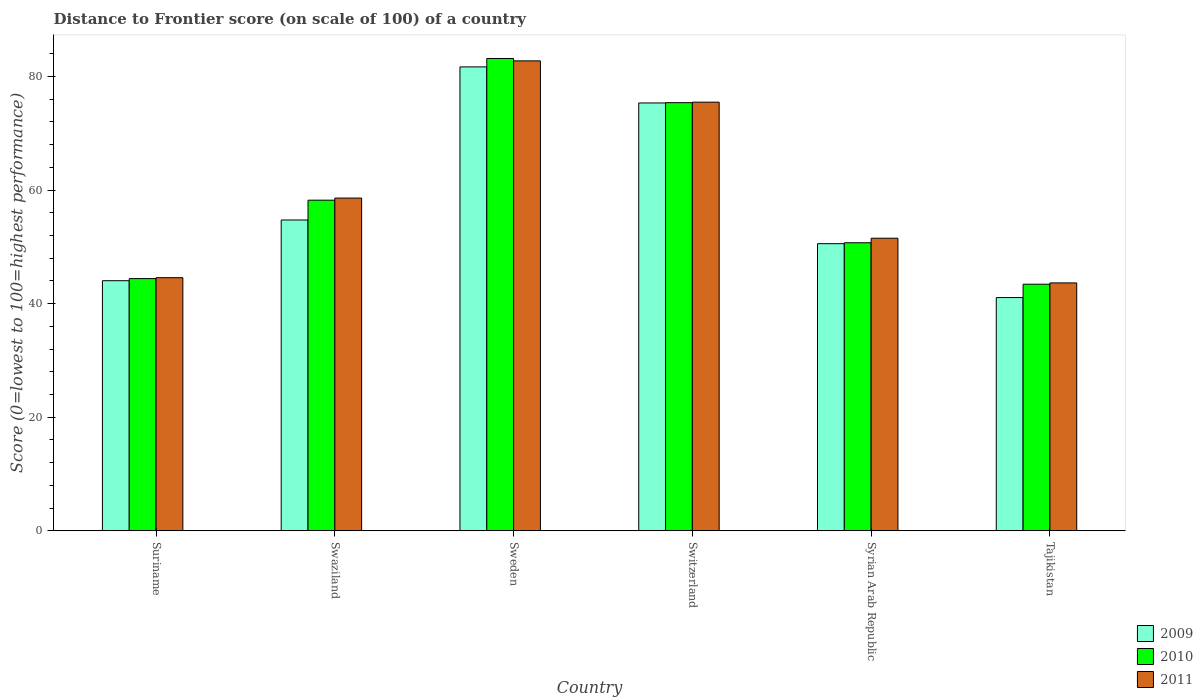How many bars are there on the 5th tick from the left?
Your answer should be compact. 3. What is the label of the 1st group of bars from the left?
Offer a terse response. Suriname. What is the distance to frontier score of in 2011 in Suriname?
Make the answer very short. 44.57. Across all countries, what is the maximum distance to frontier score of in 2010?
Your answer should be compact. 83.17. Across all countries, what is the minimum distance to frontier score of in 2009?
Provide a short and direct response. 41.07. In which country was the distance to frontier score of in 2011 minimum?
Provide a succinct answer. Tajikistan. What is the total distance to frontier score of in 2009 in the graph?
Make the answer very short. 347.43. What is the difference between the distance to frontier score of in 2009 in Switzerland and that in Syrian Arab Republic?
Keep it short and to the point. 24.78. What is the difference between the distance to frontier score of in 2010 in Swaziland and the distance to frontier score of in 2011 in Suriname?
Make the answer very short. 13.65. What is the average distance to frontier score of in 2010 per country?
Make the answer very short. 59.22. What is the difference between the distance to frontier score of of/in 2009 and distance to frontier score of of/in 2010 in Syrian Arab Republic?
Ensure brevity in your answer.  -0.16. In how many countries, is the distance to frontier score of in 2009 greater than 4?
Your response must be concise. 6. What is the ratio of the distance to frontier score of in 2011 in Syrian Arab Republic to that in Tajikistan?
Your answer should be compact. 1.18. Is the difference between the distance to frontier score of in 2009 in Syrian Arab Republic and Tajikistan greater than the difference between the distance to frontier score of in 2010 in Syrian Arab Republic and Tajikistan?
Ensure brevity in your answer.  Yes. What is the difference between the highest and the second highest distance to frontier score of in 2010?
Give a very brief answer. -7.78. What is the difference between the highest and the lowest distance to frontier score of in 2011?
Give a very brief answer. 39.1. Is it the case that in every country, the sum of the distance to frontier score of in 2010 and distance to frontier score of in 2009 is greater than the distance to frontier score of in 2011?
Make the answer very short. Yes. Are all the bars in the graph horizontal?
Your response must be concise. No. What is the difference between two consecutive major ticks on the Y-axis?
Your answer should be compact. 20. Are the values on the major ticks of Y-axis written in scientific E-notation?
Your answer should be compact. No. How many legend labels are there?
Your response must be concise. 3. How are the legend labels stacked?
Offer a terse response. Vertical. What is the title of the graph?
Ensure brevity in your answer.  Distance to Frontier score (on scale of 100) of a country. Does "2001" appear as one of the legend labels in the graph?
Provide a short and direct response. No. What is the label or title of the Y-axis?
Provide a short and direct response. Score (0=lowest to 100=highest performance). What is the Score (0=lowest to 100=highest performance) in 2009 in Suriname?
Offer a very short reply. 44.04. What is the Score (0=lowest to 100=highest performance) in 2010 in Suriname?
Provide a succinct answer. 44.41. What is the Score (0=lowest to 100=highest performance) in 2011 in Suriname?
Make the answer very short. 44.57. What is the Score (0=lowest to 100=highest performance) of 2009 in Swaziland?
Offer a very short reply. 54.73. What is the Score (0=lowest to 100=highest performance) in 2010 in Swaziland?
Give a very brief answer. 58.22. What is the Score (0=lowest to 100=highest performance) in 2011 in Swaziland?
Keep it short and to the point. 58.59. What is the Score (0=lowest to 100=highest performance) of 2009 in Sweden?
Provide a short and direct response. 81.69. What is the Score (0=lowest to 100=highest performance) of 2010 in Sweden?
Give a very brief answer. 83.17. What is the Score (0=lowest to 100=highest performance) in 2011 in Sweden?
Ensure brevity in your answer.  82.75. What is the Score (0=lowest to 100=highest performance) in 2009 in Switzerland?
Make the answer very short. 75.34. What is the Score (0=lowest to 100=highest performance) of 2010 in Switzerland?
Your answer should be very brief. 75.39. What is the Score (0=lowest to 100=highest performance) of 2011 in Switzerland?
Provide a succinct answer. 75.48. What is the Score (0=lowest to 100=highest performance) of 2009 in Syrian Arab Republic?
Provide a succinct answer. 50.56. What is the Score (0=lowest to 100=highest performance) of 2010 in Syrian Arab Republic?
Your answer should be very brief. 50.72. What is the Score (0=lowest to 100=highest performance) in 2011 in Syrian Arab Republic?
Provide a succinct answer. 51.52. What is the Score (0=lowest to 100=highest performance) of 2009 in Tajikistan?
Your answer should be very brief. 41.07. What is the Score (0=lowest to 100=highest performance) of 2010 in Tajikistan?
Ensure brevity in your answer.  43.42. What is the Score (0=lowest to 100=highest performance) in 2011 in Tajikistan?
Provide a short and direct response. 43.65. Across all countries, what is the maximum Score (0=lowest to 100=highest performance) of 2009?
Keep it short and to the point. 81.69. Across all countries, what is the maximum Score (0=lowest to 100=highest performance) in 2010?
Offer a very short reply. 83.17. Across all countries, what is the maximum Score (0=lowest to 100=highest performance) in 2011?
Give a very brief answer. 82.75. Across all countries, what is the minimum Score (0=lowest to 100=highest performance) of 2009?
Your answer should be compact. 41.07. Across all countries, what is the minimum Score (0=lowest to 100=highest performance) in 2010?
Offer a terse response. 43.42. Across all countries, what is the minimum Score (0=lowest to 100=highest performance) of 2011?
Your answer should be compact. 43.65. What is the total Score (0=lowest to 100=highest performance) of 2009 in the graph?
Your answer should be very brief. 347.43. What is the total Score (0=lowest to 100=highest performance) in 2010 in the graph?
Your answer should be very brief. 355.33. What is the total Score (0=lowest to 100=highest performance) in 2011 in the graph?
Give a very brief answer. 356.56. What is the difference between the Score (0=lowest to 100=highest performance) of 2009 in Suriname and that in Swaziland?
Provide a short and direct response. -10.69. What is the difference between the Score (0=lowest to 100=highest performance) in 2010 in Suriname and that in Swaziland?
Offer a terse response. -13.81. What is the difference between the Score (0=lowest to 100=highest performance) of 2011 in Suriname and that in Swaziland?
Your response must be concise. -14.02. What is the difference between the Score (0=lowest to 100=highest performance) of 2009 in Suriname and that in Sweden?
Your answer should be very brief. -37.65. What is the difference between the Score (0=lowest to 100=highest performance) in 2010 in Suriname and that in Sweden?
Make the answer very short. -38.76. What is the difference between the Score (0=lowest to 100=highest performance) in 2011 in Suriname and that in Sweden?
Your answer should be very brief. -38.18. What is the difference between the Score (0=lowest to 100=highest performance) of 2009 in Suriname and that in Switzerland?
Offer a very short reply. -31.3. What is the difference between the Score (0=lowest to 100=highest performance) of 2010 in Suriname and that in Switzerland?
Your answer should be very brief. -30.98. What is the difference between the Score (0=lowest to 100=highest performance) in 2011 in Suriname and that in Switzerland?
Your answer should be compact. -30.91. What is the difference between the Score (0=lowest to 100=highest performance) of 2009 in Suriname and that in Syrian Arab Republic?
Your answer should be compact. -6.52. What is the difference between the Score (0=lowest to 100=highest performance) of 2010 in Suriname and that in Syrian Arab Republic?
Ensure brevity in your answer.  -6.31. What is the difference between the Score (0=lowest to 100=highest performance) of 2011 in Suriname and that in Syrian Arab Republic?
Make the answer very short. -6.95. What is the difference between the Score (0=lowest to 100=highest performance) of 2009 in Suriname and that in Tajikistan?
Provide a succinct answer. 2.97. What is the difference between the Score (0=lowest to 100=highest performance) of 2010 in Suriname and that in Tajikistan?
Keep it short and to the point. 0.99. What is the difference between the Score (0=lowest to 100=highest performance) of 2009 in Swaziland and that in Sweden?
Your answer should be very brief. -26.96. What is the difference between the Score (0=lowest to 100=highest performance) in 2010 in Swaziland and that in Sweden?
Offer a very short reply. -24.95. What is the difference between the Score (0=lowest to 100=highest performance) in 2011 in Swaziland and that in Sweden?
Ensure brevity in your answer.  -24.16. What is the difference between the Score (0=lowest to 100=highest performance) in 2009 in Swaziland and that in Switzerland?
Your answer should be compact. -20.61. What is the difference between the Score (0=lowest to 100=highest performance) in 2010 in Swaziland and that in Switzerland?
Your response must be concise. -17.17. What is the difference between the Score (0=lowest to 100=highest performance) of 2011 in Swaziland and that in Switzerland?
Offer a terse response. -16.89. What is the difference between the Score (0=lowest to 100=highest performance) of 2009 in Swaziland and that in Syrian Arab Republic?
Offer a terse response. 4.17. What is the difference between the Score (0=lowest to 100=highest performance) in 2010 in Swaziland and that in Syrian Arab Republic?
Provide a short and direct response. 7.5. What is the difference between the Score (0=lowest to 100=highest performance) in 2011 in Swaziland and that in Syrian Arab Republic?
Provide a succinct answer. 7.07. What is the difference between the Score (0=lowest to 100=highest performance) in 2009 in Swaziland and that in Tajikistan?
Make the answer very short. 13.66. What is the difference between the Score (0=lowest to 100=highest performance) in 2010 in Swaziland and that in Tajikistan?
Keep it short and to the point. 14.8. What is the difference between the Score (0=lowest to 100=highest performance) in 2011 in Swaziland and that in Tajikistan?
Your answer should be compact. 14.94. What is the difference between the Score (0=lowest to 100=highest performance) of 2009 in Sweden and that in Switzerland?
Offer a very short reply. 6.35. What is the difference between the Score (0=lowest to 100=highest performance) of 2010 in Sweden and that in Switzerland?
Provide a succinct answer. 7.78. What is the difference between the Score (0=lowest to 100=highest performance) of 2011 in Sweden and that in Switzerland?
Provide a short and direct response. 7.27. What is the difference between the Score (0=lowest to 100=highest performance) in 2009 in Sweden and that in Syrian Arab Republic?
Your answer should be compact. 31.13. What is the difference between the Score (0=lowest to 100=highest performance) of 2010 in Sweden and that in Syrian Arab Republic?
Provide a short and direct response. 32.45. What is the difference between the Score (0=lowest to 100=highest performance) in 2011 in Sweden and that in Syrian Arab Republic?
Keep it short and to the point. 31.23. What is the difference between the Score (0=lowest to 100=highest performance) in 2009 in Sweden and that in Tajikistan?
Ensure brevity in your answer.  40.62. What is the difference between the Score (0=lowest to 100=highest performance) in 2010 in Sweden and that in Tajikistan?
Ensure brevity in your answer.  39.75. What is the difference between the Score (0=lowest to 100=highest performance) in 2011 in Sweden and that in Tajikistan?
Provide a succinct answer. 39.1. What is the difference between the Score (0=lowest to 100=highest performance) in 2009 in Switzerland and that in Syrian Arab Republic?
Your answer should be compact. 24.78. What is the difference between the Score (0=lowest to 100=highest performance) in 2010 in Switzerland and that in Syrian Arab Republic?
Give a very brief answer. 24.67. What is the difference between the Score (0=lowest to 100=highest performance) of 2011 in Switzerland and that in Syrian Arab Republic?
Provide a succinct answer. 23.96. What is the difference between the Score (0=lowest to 100=highest performance) in 2009 in Switzerland and that in Tajikistan?
Make the answer very short. 34.27. What is the difference between the Score (0=lowest to 100=highest performance) in 2010 in Switzerland and that in Tajikistan?
Offer a very short reply. 31.97. What is the difference between the Score (0=lowest to 100=highest performance) of 2011 in Switzerland and that in Tajikistan?
Offer a very short reply. 31.83. What is the difference between the Score (0=lowest to 100=highest performance) in 2009 in Syrian Arab Republic and that in Tajikistan?
Provide a short and direct response. 9.49. What is the difference between the Score (0=lowest to 100=highest performance) in 2011 in Syrian Arab Republic and that in Tajikistan?
Ensure brevity in your answer.  7.87. What is the difference between the Score (0=lowest to 100=highest performance) in 2009 in Suriname and the Score (0=lowest to 100=highest performance) in 2010 in Swaziland?
Your answer should be very brief. -14.18. What is the difference between the Score (0=lowest to 100=highest performance) of 2009 in Suriname and the Score (0=lowest to 100=highest performance) of 2011 in Swaziland?
Keep it short and to the point. -14.55. What is the difference between the Score (0=lowest to 100=highest performance) in 2010 in Suriname and the Score (0=lowest to 100=highest performance) in 2011 in Swaziland?
Your answer should be very brief. -14.18. What is the difference between the Score (0=lowest to 100=highest performance) in 2009 in Suriname and the Score (0=lowest to 100=highest performance) in 2010 in Sweden?
Keep it short and to the point. -39.13. What is the difference between the Score (0=lowest to 100=highest performance) of 2009 in Suriname and the Score (0=lowest to 100=highest performance) of 2011 in Sweden?
Provide a succinct answer. -38.71. What is the difference between the Score (0=lowest to 100=highest performance) in 2010 in Suriname and the Score (0=lowest to 100=highest performance) in 2011 in Sweden?
Ensure brevity in your answer.  -38.34. What is the difference between the Score (0=lowest to 100=highest performance) in 2009 in Suriname and the Score (0=lowest to 100=highest performance) in 2010 in Switzerland?
Your response must be concise. -31.35. What is the difference between the Score (0=lowest to 100=highest performance) of 2009 in Suriname and the Score (0=lowest to 100=highest performance) of 2011 in Switzerland?
Provide a short and direct response. -31.44. What is the difference between the Score (0=lowest to 100=highest performance) in 2010 in Suriname and the Score (0=lowest to 100=highest performance) in 2011 in Switzerland?
Offer a terse response. -31.07. What is the difference between the Score (0=lowest to 100=highest performance) of 2009 in Suriname and the Score (0=lowest to 100=highest performance) of 2010 in Syrian Arab Republic?
Give a very brief answer. -6.68. What is the difference between the Score (0=lowest to 100=highest performance) in 2009 in Suriname and the Score (0=lowest to 100=highest performance) in 2011 in Syrian Arab Republic?
Your response must be concise. -7.48. What is the difference between the Score (0=lowest to 100=highest performance) of 2010 in Suriname and the Score (0=lowest to 100=highest performance) of 2011 in Syrian Arab Republic?
Offer a terse response. -7.11. What is the difference between the Score (0=lowest to 100=highest performance) in 2009 in Suriname and the Score (0=lowest to 100=highest performance) in 2010 in Tajikistan?
Your response must be concise. 0.62. What is the difference between the Score (0=lowest to 100=highest performance) in 2009 in Suriname and the Score (0=lowest to 100=highest performance) in 2011 in Tajikistan?
Provide a succinct answer. 0.39. What is the difference between the Score (0=lowest to 100=highest performance) of 2010 in Suriname and the Score (0=lowest to 100=highest performance) of 2011 in Tajikistan?
Keep it short and to the point. 0.76. What is the difference between the Score (0=lowest to 100=highest performance) in 2009 in Swaziland and the Score (0=lowest to 100=highest performance) in 2010 in Sweden?
Your answer should be very brief. -28.44. What is the difference between the Score (0=lowest to 100=highest performance) in 2009 in Swaziland and the Score (0=lowest to 100=highest performance) in 2011 in Sweden?
Keep it short and to the point. -28.02. What is the difference between the Score (0=lowest to 100=highest performance) in 2010 in Swaziland and the Score (0=lowest to 100=highest performance) in 2011 in Sweden?
Make the answer very short. -24.53. What is the difference between the Score (0=lowest to 100=highest performance) of 2009 in Swaziland and the Score (0=lowest to 100=highest performance) of 2010 in Switzerland?
Make the answer very short. -20.66. What is the difference between the Score (0=lowest to 100=highest performance) in 2009 in Swaziland and the Score (0=lowest to 100=highest performance) in 2011 in Switzerland?
Provide a short and direct response. -20.75. What is the difference between the Score (0=lowest to 100=highest performance) in 2010 in Swaziland and the Score (0=lowest to 100=highest performance) in 2011 in Switzerland?
Your answer should be very brief. -17.26. What is the difference between the Score (0=lowest to 100=highest performance) in 2009 in Swaziland and the Score (0=lowest to 100=highest performance) in 2010 in Syrian Arab Republic?
Your answer should be very brief. 4.01. What is the difference between the Score (0=lowest to 100=highest performance) in 2009 in Swaziland and the Score (0=lowest to 100=highest performance) in 2011 in Syrian Arab Republic?
Keep it short and to the point. 3.21. What is the difference between the Score (0=lowest to 100=highest performance) of 2009 in Swaziland and the Score (0=lowest to 100=highest performance) of 2010 in Tajikistan?
Offer a terse response. 11.31. What is the difference between the Score (0=lowest to 100=highest performance) in 2009 in Swaziland and the Score (0=lowest to 100=highest performance) in 2011 in Tajikistan?
Provide a short and direct response. 11.08. What is the difference between the Score (0=lowest to 100=highest performance) of 2010 in Swaziland and the Score (0=lowest to 100=highest performance) of 2011 in Tajikistan?
Offer a very short reply. 14.57. What is the difference between the Score (0=lowest to 100=highest performance) of 2009 in Sweden and the Score (0=lowest to 100=highest performance) of 2010 in Switzerland?
Your response must be concise. 6.3. What is the difference between the Score (0=lowest to 100=highest performance) in 2009 in Sweden and the Score (0=lowest to 100=highest performance) in 2011 in Switzerland?
Give a very brief answer. 6.21. What is the difference between the Score (0=lowest to 100=highest performance) of 2010 in Sweden and the Score (0=lowest to 100=highest performance) of 2011 in Switzerland?
Offer a very short reply. 7.69. What is the difference between the Score (0=lowest to 100=highest performance) of 2009 in Sweden and the Score (0=lowest to 100=highest performance) of 2010 in Syrian Arab Republic?
Provide a succinct answer. 30.97. What is the difference between the Score (0=lowest to 100=highest performance) of 2009 in Sweden and the Score (0=lowest to 100=highest performance) of 2011 in Syrian Arab Republic?
Give a very brief answer. 30.17. What is the difference between the Score (0=lowest to 100=highest performance) in 2010 in Sweden and the Score (0=lowest to 100=highest performance) in 2011 in Syrian Arab Republic?
Your answer should be very brief. 31.65. What is the difference between the Score (0=lowest to 100=highest performance) in 2009 in Sweden and the Score (0=lowest to 100=highest performance) in 2010 in Tajikistan?
Keep it short and to the point. 38.27. What is the difference between the Score (0=lowest to 100=highest performance) in 2009 in Sweden and the Score (0=lowest to 100=highest performance) in 2011 in Tajikistan?
Provide a short and direct response. 38.04. What is the difference between the Score (0=lowest to 100=highest performance) of 2010 in Sweden and the Score (0=lowest to 100=highest performance) of 2011 in Tajikistan?
Your response must be concise. 39.52. What is the difference between the Score (0=lowest to 100=highest performance) in 2009 in Switzerland and the Score (0=lowest to 100=highest performance) in 2010 in Syrian Arab Republic?
Make the answer very short. 24.62. What is the difference between the Score (0=lowest to 100=highest performance) in 2009 in Switzerland and the Score (0=lowest to 100=highest performance) in 2011 in Syrian Arab Republic?
Ensure brevity in your answer.  23.82. What is the difference between the Score (0=lowest to 100=highest performance) of 2010 in Switzerland and the Score (0=lowest to 100=highest performance) of 2011 in Syrian Arab Republic?
Ensure brevity in your answer.  23.87. What is the difference between the Score (0=lowest to 100=highest performance) of 2009 in Switzerland and the Score (0=lowest to 100=highest performance) of 2010 in Tajikistan?
Make the answer very short. 31.92. What is the difference between the Score (0=lowest to 100=highest performance) in 2009 in Switzerland and the Score (0=lowest to 100=highest performance) in 2011 in Tajikistan?
Provide a succinct answer. 31.69. What is the difference between the Score (0=lowest to 100=highest performance) of 2010 in Switzerland and the Score (0=lowest to 100=highest performance) of 2011 in Tajikistan?
Ensure brevity in your answer.  31.74. What is the difference between the Score (0=lowest to 100=highest performance) in 2009 in Syrian Arab Republic and the Score (0=lowest to 100=highest performance) in 2010 in Tajikistan?
Offer a terse response. 7.14. What is the difference between the Score (0=lowest to 100=highest performance) in 2009 in Syrian Arab Republic and the Score (0=lowest to 100=highest performance) in 2011 in Tajikistan?
Offer a terse response. 6.91. What is the difference between the Score (0=lowest to 100=highest performance) of 2010 in Syrian Arab Republic and the Score (0=lowest to 100=highest performance) of 2011 in Tajikistan?
Offer a very short reply. 7.07. What is the average Score (0=lowest to 100=highest performance) in 2009 per country?
Your response must be concise. 57.91. What is the average Score (0=lowest to 100=highest performance) of 2010 per country?
Provide a succinct answer. 59.22. What is the average Score (0=lowest to 100=highest performance) of 2011 per country?
Provide a short and direct response. 59.43. What is the difference between the Score (0=lowest to 100=highest performance) in 2009 and Score (0=lowest to 100=highest performance) in 2010 in Suriname?
Offer a terse response. -0.37. What is the difference between the Score (0=lowest to 100=highest performance) of 2009 and Score (0=lowest to 100=highest performance) of 2011 in Suriname?
Your answer should be very brief. -0.53. What is the difference between the Score (0=lowest to 100=highest performance) of 2010 and Score (0=lowest to 100=highest performance) of 2011 in Suriname?
Make the answer very short. -0.16. What is the difference between the Score (0=lowest to 100=highest performance) in 2009 and Score (0=lowest to 100=highest performance) in 2010 in Swaziland?
Give a very brief answer. -3.49. What is the difference between the Score (0=lowest to 100=highest performance) in 2009 and Score (0=lowest to 100=highest performance) in 2011 in Swaziland?
Provide a succinct answer. -3.86. What is the difference between the Score (0=lowest to 100=highest performance) of 2010 and Score (0=lowest to 100=highest performance) of 2011 in Swaziland?
Your answer should be very brief. -0.37. What is the difference between the Score (0=lowest to 100=highest performance) of 2009 and Score (0=lowest to 100=highest performance) of 2010 in Sweden?
Your response must be concise. -1.48. What is the difference between the Score (0=lowest to 100=highest performance) in 2009 and Score (0=lowest to 100=highest performance) in 2011 in Sweden?
Your answer should be compact. -1.06. What is the difference between the Score (0=lowest to 100=highest performance) of 2010 and Score (0=lowest to 100=highest performance) of 2011 in Sweden?
Your response must be concise. 0.42. What is the difference between the Score (0=lowest to 100=highest performance) of 2009 and Score (0=lowest to 100=highest performance) of 2010 in Switzerland?
Make the answer very short. -0.05. What is the difference between the Score (0=lowest to 100=highest performance) of 2009 and Score (0=lowest to 100=highest performance) of 2011 in Switzerland?
Offer a very short reply. -0.14. What is the difference between the Score (0=lowest to 100=highest performance) of 2010 and Score (0=lowest to 100=highest performance) of 2011 in Switzerland?
Your answer should be very brief. -0.09. What is the difference between the Score (0=lowest to 100=highest performance) in 2009 and Score (0=lowest to 100=highest performance) in 2010 in Syrian Arab Republic?
Offer a terse response. -0.16. What is the difference between the Score (0=lowest to 100=highest performance) in 2009 and Score (0=lowest to 100=highest performance) in 2011 in Syrian Arab Republic?
Give a very brief answer. -0.96. What is the difference between the Score (0=lowest to 100=highest performance) in 2009 and Score (0=lowest to 100=highest performance) in 2010 in Tajikistan?
Make the answer very short. -2.35. What is the difference between the Score (0=lowest to 100=highest performance) in 2009 and Score (0=lowest to 100=highest performance) in 2011 in Tajikistan?
Make the answer very short. -2.58. What is the difference between the Score (0=lowest to 100=highest performance) of 2010 and Score (0=lowest to 100=highest performance) of 2011 in Tajikistan?
Offer a terse response. -0.23. What is the ratio of the Score (0=lowest to 100=highest performance) in 2009 in Suriname to that in Swaziland?
Provide a succinct answer. 0.8. What is the ratio of the Score (0=lowest to 100=highest performance) in 2010 in Suriname to that in Swaziland?
Give a very brief answer. 0.76. What is the ratio of the Score (0=lowest to 100=highest performance) of 2011 in Suriname to that in Swaziland?
Give a very brief answer. 0.76. What is the ratio of the Score (0=lowest to 100=highest performance) in 2009 in Suriname to that in Sweden?
Offer a very short reply. 0.54. What is the ratio of the Score (0=lowest to 100=highest performance) of 2010 in Suriname to that in Sweden?
Your answer should be very brief. 0.53. What is the ratio of the Score (0=lowest to 100=highest performance) in 2011 in Suriname to that in Sweden?
Provide a short and direct response. 0.54. What is the ratio of the Score (0=lowest to 100=highest performance) of 2009 in Suriname to that in Switzerland?
Give a very brief answer. 0.58. What is the ratio of the Score (0=lowest to 100=highest performance) in 2010 in Suriname to that in Switzerland?
Offer a terse response. 0.59. What is the ratio of the Score (0=lowest to 100=highest performance) in 2011 in Suriname to that in Switzerland?
Offer a very short reply. 0.59. What is the ratio of the Score (0=lowest to 100=highest performance) of 2009 in Suriname to that in Syrian Arab Republic?
Give a very brief answer. 0.87. What is the ratio of the Score (0=lowest to 100=highest performance) in 2010 in Suriname to that in Syrian Arab Republic?
Your answer should be compact. 0.88. What is the ratio of the Score (0=lowest to 100=highest performance) of 2011 in Suriname to that in Syrian Arab Republic?
Keep it short and to the point. 0.87. What is the ratio of the Score (0=lowest to 100=highest performance) of 2009 in Suriname to that in Tajikistan?
Give a very brief answer. 1.07. What is the ratio of the Score (0=lowest to 100=highest performance) of 2010 in Suriname to that in Tajikistan?
Your answer should be very brief. 1.02. What is the ratio of the Score (0=lowest to 100=highest performance) of 2011 in Suriname to that in Tajikistan?
Keep it short and to the point. 1.02. What is the ratio of the Score (0=lowest to 100=highest performance) of 2009 in Swaziland to that in Sweden?
Your answer should be very brief. 0.67. What is the ratio of the Score (0=lowest to 100=highest performance) in 2011 in Swaziland to that in Sweden?
Provide a succinct answer. 0.71. What is the ratio of the Score (0=lowest to 100=highest performance) of 2009 in Swaziland to that in Switzerland?
Give a very brief answer. 0.73. What is the ratio of the Score (0=lowest to 100=highest performance) in 2010 in Swaziland to that in Switzerland?
Make the answer very short. 0.77. What is the ratio of the Score (0=lowest to 100=highest performance) of 2011 in Swaziland to that in Switzerland?
Make the answer very short. 0.78. What is the ratio of the Score (0=lowest to 100=highest performance) in 2009 in Swaziland to that in Syrian Arab Republic?
Ensure brevity in your answer.  1.08. What is the ratio of the Score (0=lowest to 100=highest performance) in 2010 in Swaziland to that in Syrian Arab Republic?
Offer a very short reply. 1.15. What is the ratio of the Score (0=lowest to 100=highest performance) in 2011 in Swaziland to that in Syrian Arab Republic?
Keep it short and to the point. 1.14. What is the ratio of the Score (0=lowest to 100=highest performance) of 2009 in Swaziland to that in Tajikistan?
Offer a very short reply. 1.33. What is the ratio of the Score (0=lowest to 100=highest performance) in 2010 in Swaziland to that in Tajikistan?
Your answer should be very brief. 1.34. What is the ratio of the Score (0=lowest to 100=highest performance) in 2011 in Swaziland to that in Tajikistan?
Your answer should be very brief. 1.34. What is the ratio of the Score (0=lowest to 100=highest performance) in 2009 in Sweden to that in Switzerland?
Provide a short and direct response. 1.08. What is the ratio of the Score (0=lowest to 100=highest performance) in 2010 in Sweden to that in Switzerland?
Keep it short and to the point. 1.1. What is the ratio of the Score (0=lowest to 100=highest performance) in 2011 in Sweden to that in Switzerland?
Your answer should be very brief. 1.1. What is the ratio of the Score (0=lowest to 100=highest performance) of 2009 in Sweden to that in Syrian Arab Republic?
Provide a short and direct response. 1.62. What is the ratio of the Score (0=lowest to 100=highest performance) in 2010 in Sweden to that in Syrian Arab Republic?
Your answer should be very brief. 1.64. What is the ratio of the Score (0=lowest to 100=highest performance) in 2011 in Sweden to that in Syrian Arab Republic?
Provide a succinct answer. 1.61. What is the ratio of the Score (0=lowest to 100=highest performance) of 2009 in Sweden to that in Tajikistan?
Give a very brief answer. 1.99. What is the ratio of the Score (0=lowest to 100=highest performance) in 2010 in Sweden to that in Tajikistan?
Your answer should be compact. 1.92. What is the ratio of the Score (0=lowest to 100=highest performance) of 2011 in Sweden to that in Tajikistan?
Ensure brevity in your answer.  1.9. What is the ratio of the Score (0=lowest to 100=highest performance) of 2009 in Switzerland to that in Syrian Arab Republic?
Provide a short and direct response. 1.49. What is the ratio of the Score (0=lowest to 100=highest performance) in 2010 in Switzerland to that in Syrian Arab Republic?
Provide a succinct answer. 1.49. What is the ratio of the Score (0=lowest to 100=highest performance) of 2011 in Switzerland to that in Syrian Arab Republic?
Make the answer very short. 1.47. What is the ratio of the Score (0=lowest to 100=highest performance) of 2009 in Switzerland to that in Tajikistan?
Offer a very short reply. 1.83. What is the ratio of the Score (0=lowest to 100=highest performance) of 2010 in Switzerland to that in Tajikistan?
Keep it short and to the point. 1.74. What is the ratio of the Score (0=lowest to 100=highest performance) of 2011 in Switzerland to that in Tajikistan?
Make the answer very short. 1.73. What is the ratio of the Score (0=lowest to 100=highest performance) in 2009 in Syrian Arab Republic to that in Tajikistan?
Provide a short and direct response. 1.23. What is the ratio of the Score (0=lowest to 100=highest performance) in 2010 in Syrian Arab Republic to that in Tajikistan?
Ensure brevity in your answer.  1.17. What is the ratio of the Score (0=lowest to 100=highest performance) in 2011 in Syrian Arab Republic to that in Tajikistan?
Offer a very short reply. 1.18. What is the difference between the highest and the second highest Score (0=lowest to 100=highest performance) in 2009?
Your response must be concise. 6.35. What is the difference between the highest and the second highest Score (0=lowest to 100=highest performance) in 2010?
Your response must be concise. 7.78. What is the difference between the highest and the second highest Score (0=lowest to 100=highest performance) of 2011?
Your response must be concise. 7.27. What is the difference between the highest and the lowest Score (0=lowest to 100=highest performance) of 2009?
Provide a short and direct response. 40.62. What is the difference between the highest and the lowest Score (0=lowest to 100=highest performance) of 2010?
Offer a very short reply. 39.75. What is the difference between the highest and the lowest Score (0=lowest to 100=highest performance) of 2011?
Your response must be concise. 39.1. 